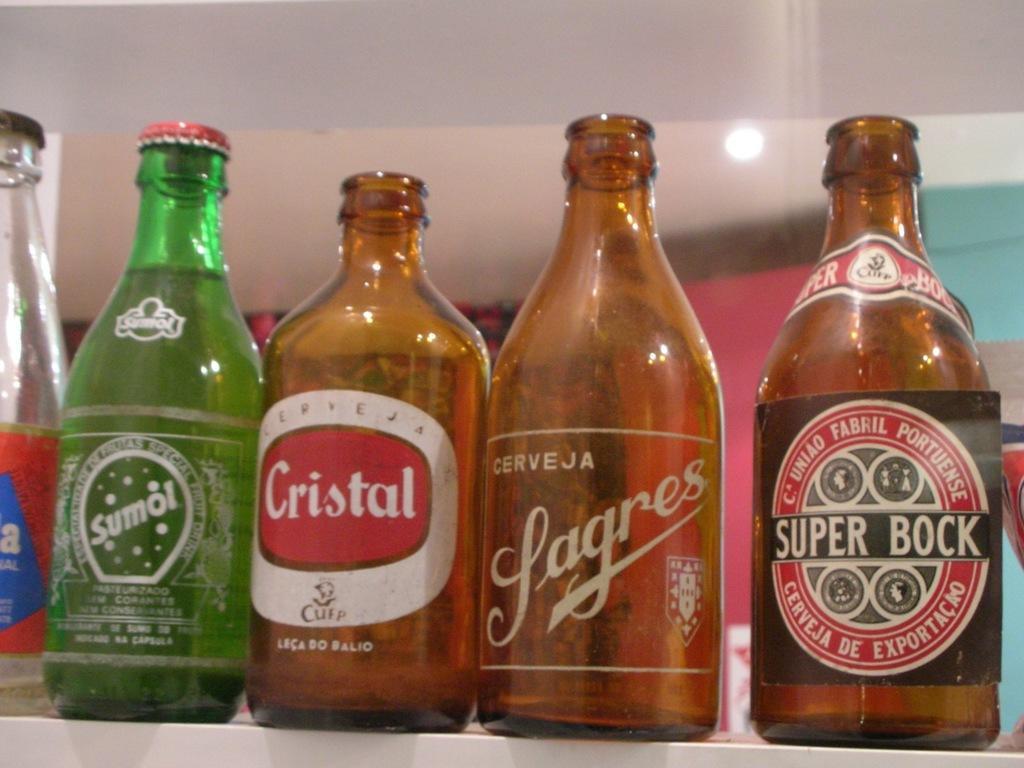How would you summarize this image in a sentence or two? This picture shows bottles and a light 